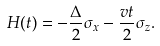<formula> <loc_0><loc_0><loc_500><loc_500>H ( t ) = - \frac { \Delta } { 2 } \sigma _ { x } - \frac { v t } { 2 } \sigma _ { z } .</formula> 